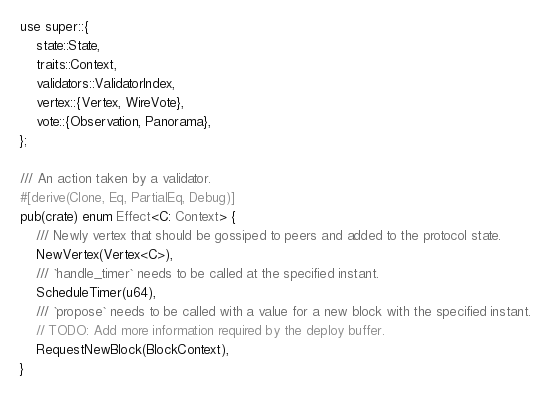Convert code to text. <code><loc_0><loc_0><loc_500><loc_500><_Rust_>use super::{
    state::State,
    traits::Context,
    validators::ValidatorIndex,
    vertex::{Vertex, WireVote},
    vote::{Observation, Panorama},
};

/// An action taken by a validator.
#[derive(Clone, Eq, PartialEq, Debug)]
pub(crate) enum Effect<C: Context> {
    /// Newly vertex that should be gossiped to peers and added to the protocol state.
    NewVertex(Vertex<C>),
    /// `handle_timer` needs to be called at the specified instant.
    ScheduleTimer(u64),
    /// `propose` needs to be called with a value for a new block with the specified instant.
    // TODO: Add more information required by the deploy buffer.
    RequestNewBlock(BlockContext),
}
</code> 